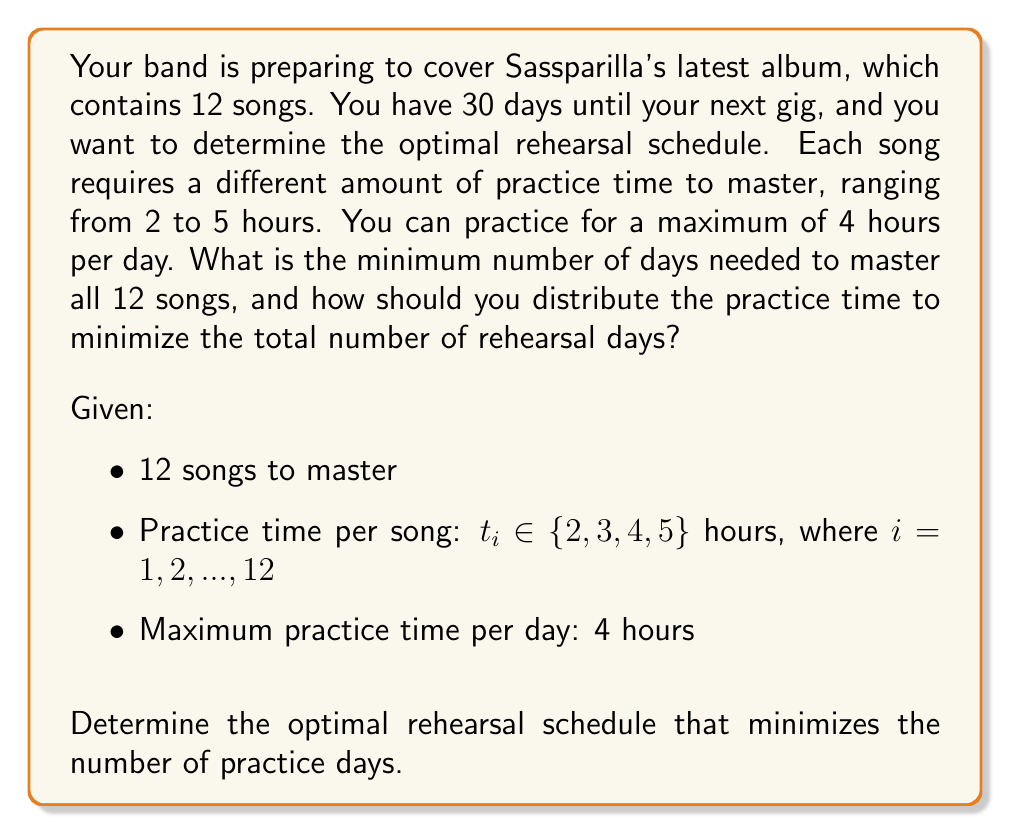Show me your answer to this math problem. To solve this problem, we'll use a greedy algorithm approach combined with the bin packing problem concept. Here's the step-by-step solution:

1. First, we need to calculate the total practice time required:
   $$T_{total} = \sum_{i=1}^{12} t_i$$

2. The minimum number of days required would be:
   $$D_{min} = \left\lceil\frac{T_{total}}{4}\right\rceil$$
   
   Where $\lceil \cdot \rceil$ represents the ceiling function.

3. To minimize the number of practice days, we should try to fill each day with exactly 4 hours of practice. This is similar to the bin packing problem, where each day is a bin with a capacity of 4 hours.

4. Sort the songs in descending order based on their required practice time. This allows us to place the most time-consuming songs first.

5. Use a greedy algorithm to assign songs to days:
   a. Start with the first day.
   b. Add songs to the current day, starting with the longest practice time, until adding another song would exceed 4 hours.
   c. Move to the next day and repeat step b until all songs are assigned.

6. Count the number of days used in the schedule. This will be our optimal solution.

The exact distribution of songs per day will depend on the specific practice times for each song. However, this approach guarantees that we will use the minimum number of days possible.

For example, if the practice times for the 12 songs are:
$$[5, 5, 4, 4, 3, 3, 3, 3, 2, 2, 2, 2]$$

The optimal schedule might look like:
- Day 1: 5 + 3 = 8 hours (split into two 4-hour sessions)
- Day 2: 5 + 3 = 8 hours (split into two 4-hour sessions)
- Day 3: 4 + 4 = 8 hours (split into two 4-hour sessions)
- Day 4: 3 + 3 + 2 = 8 hours (split into two 4-hour sessions)
- Day 5: 2 + 2 + 2 = 6 hours

This schedule uses 5 days, which is the minimum possible given the constraints.
Answer: The minimum number of days needed to master all 12 songs is 5, assuming the practice times are distributed as in the example. The optimal rehearsal schedule should be determined using a greedy algorithm approach, assigning songs to days in descending order of practice time, filling each day with up to 4 hours of practice. 